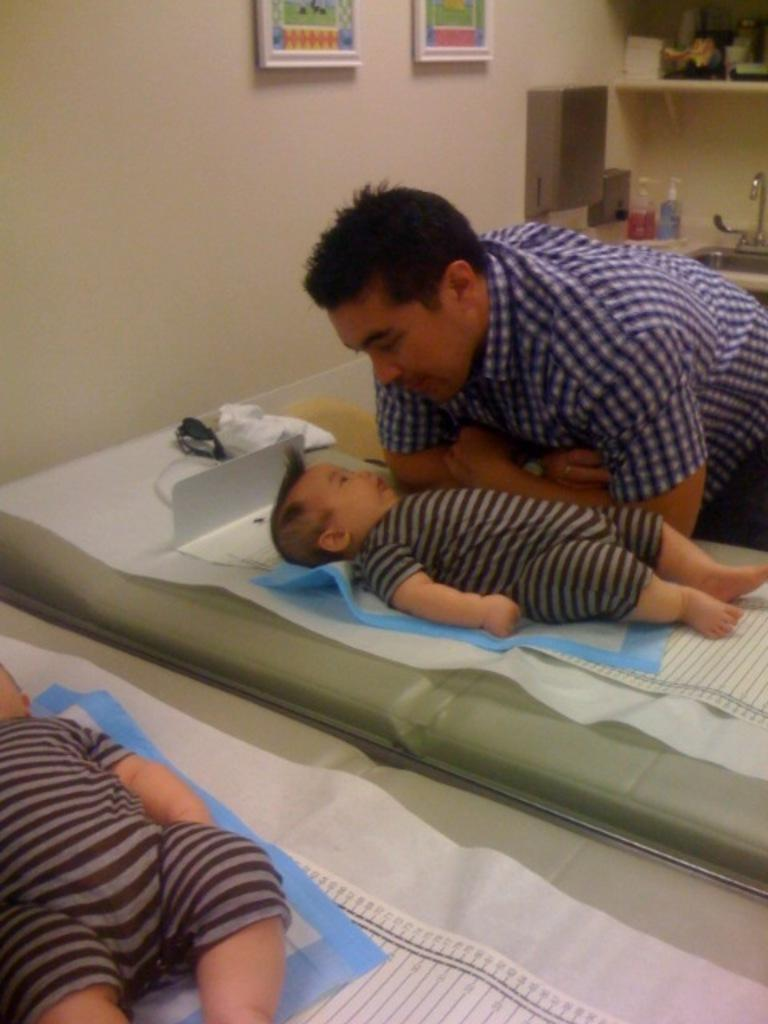How many babies are in the image? There are two babies lying on beds in the image. What is the man in the image doing? The man is smiling in the image. What can be seen on the wall in the image? There are frames on the wall in the image. What is visible in the background of the image? In the background, there are objects in racks, a tap, a sink, and bottles. What type of teeth can be seen in the image? There are no teeth visible in the image. How many kittens are present in the image? There are no kittens present in the image. 